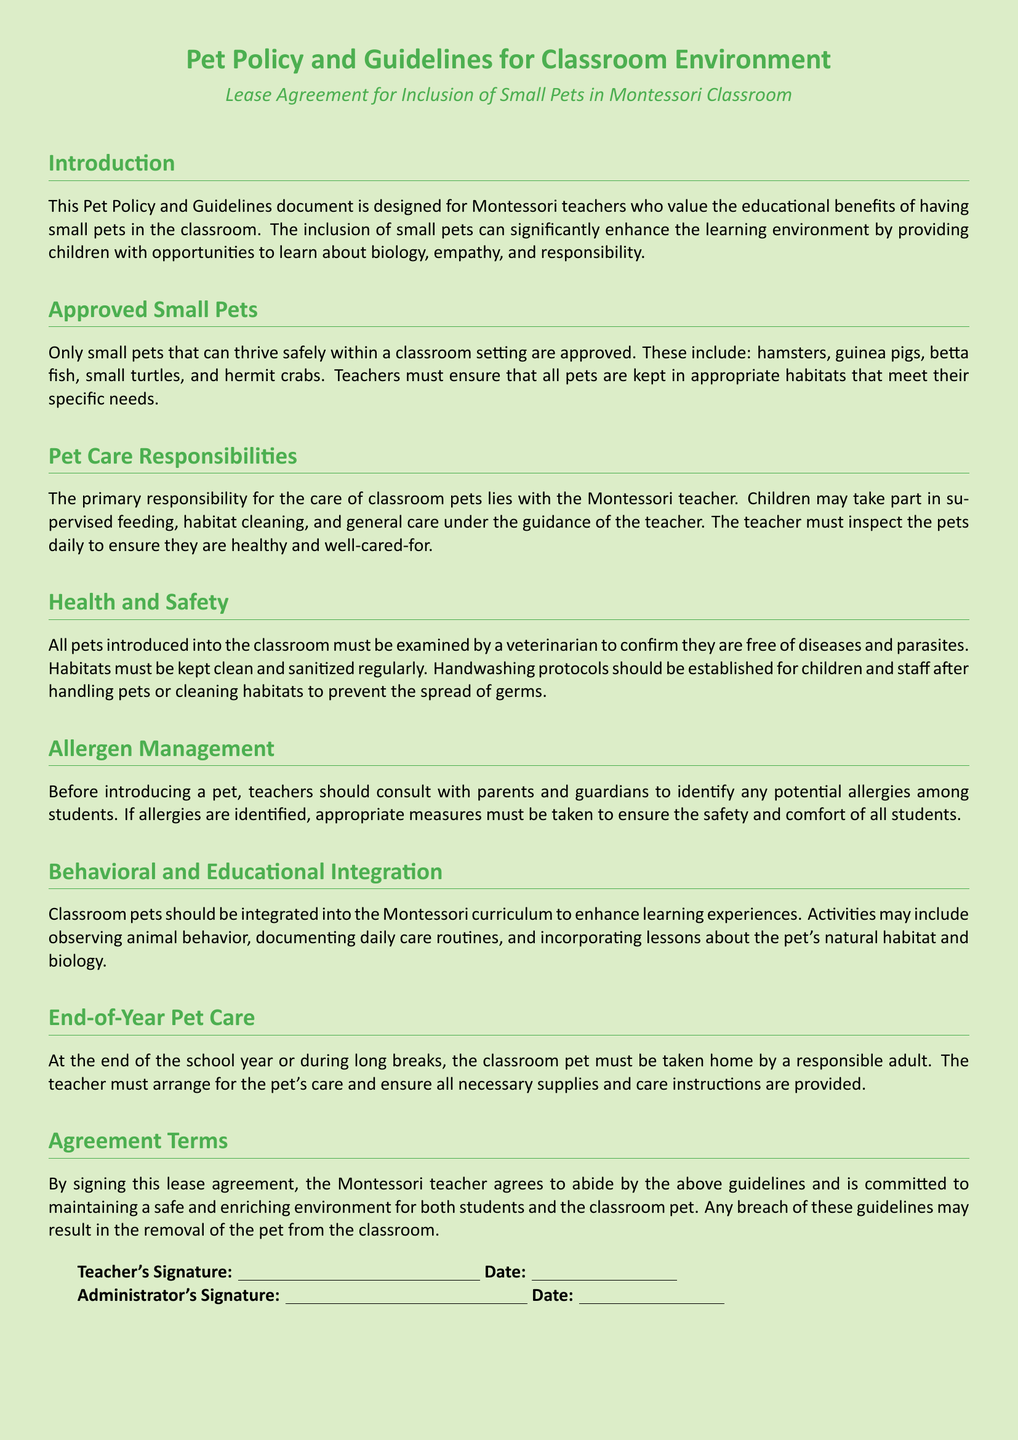What types of small pets are approved for the classroom? The document lists approved small pets that are safe for the classroom environment, including hamsters and guinea pigs.
Answer: hamsters, guinea pigs, betta fish, small turtles, hermit crabs Who holds the primary responsibility for the care of classroom pets? The document specifies that the primary responsibility for pet care lies with the Montessori teacher.
Answer: Montessori teacher What must be established after handling pets or cleaning habitats? The document indicates that handwashing protocols should be established for both children and staff.
Answer: handwashing protocols What should teachers consult with parents about before introducing a pet? The document emphasizes that teachers should consult with parents to identify any potential allergies among students.
Answer: potential allergies What happens to the classroom pet at the end of the school year? According to the document, the classroom pet must be taken home by a responsible adult at the end of the school year.
Answer: taken home by a responsible adult What is required of pets before they are introduced into the classroom? The document states that all pets must be examined by a veterinarian to confirm they are free of diseases and parasites.
Answer: examined by a veterinarian What may result from a breach of the guidelines in the agreement? The document mentions that any breach of these guidelines may result in the removal of the pet from the classroom.
Answer: removal of the pet What is a key educational activity suggested in the guidelines? The document suggests activities such as observing animal behavior to enhance the learning experience.
Answer: observing animal behavior 